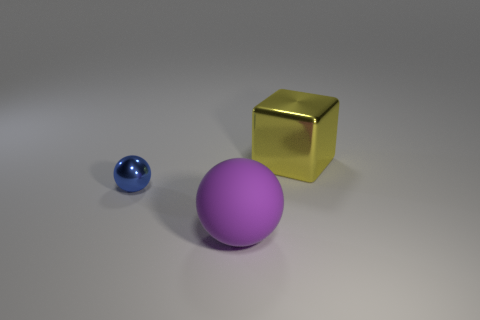Add 1 tiny green things. How many objects exist? 4 Subtract all blocks. How many objects are left? 2 Subtract all tiny red things. Subtract all purple objects. How many objects are left? 2 Add 1 big purple balls. How many big purple balls are left? 2 Add 1 purple shiny blocks. How many purple shiny blocks exist? 1 Subtract 0 green cylinders. How many objects are left? 3 